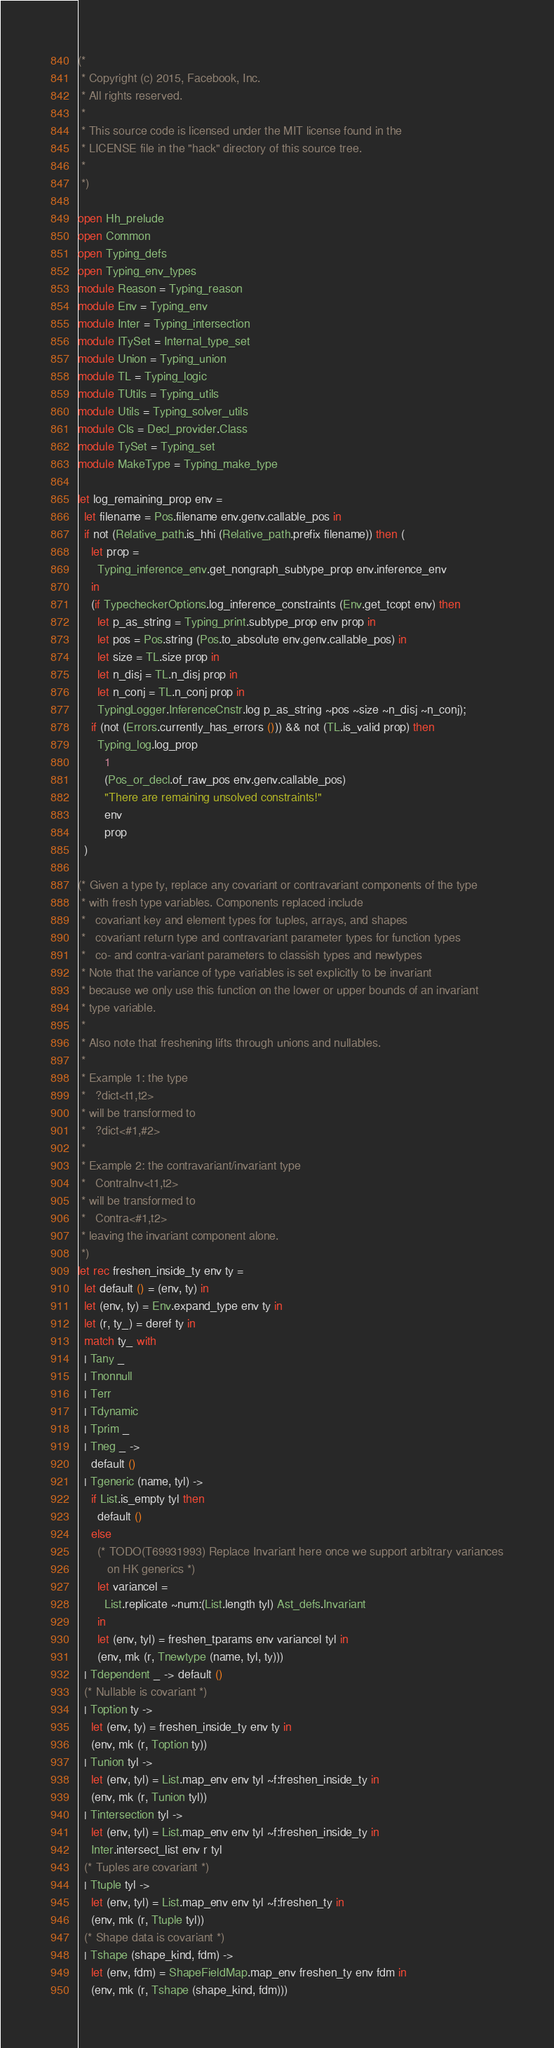<code> <loc_0><loc_0><loc_500><loc_500><_OCaml_>(*
 * Copyright (c) 2015, Facebook, Inc.
 * All rights reserved.
 *
 * This source code is licensed under the MIT license found in the
 * LICENSE file in the "hack" directory of this source tree.
 *
 *)

open Hh_prelude
open Common
open Typing_defs
open Typing_env_types
module Reason = Typing_reason
module Env = Typing_env
module Inter = Typing_intersection
module ITySet = Internal_type_set
module Union = Typing_union
module TL = Typing_logic
module TUtils = Typing_utils
module Utils = Typing_solver_utils
module Cls = Decl_provider.Class
module TySet = Typing_set
module MakeType = Typing_make_type

let log_remaining_prop env =
  let filename = Pos.filename env.genv.callable_pos in
  if not (Relative_path.is_hhi (Relative_path.prefix filename)) then (
    let prop =
      Typing_inference_env.get_nongraph_subtype_prop env.inference_env
    in
    (if TypecheckerOptions.log_inference_constraints (Env.get_tcopt env) then
      let p_as_string = Typing_print.subtype_prop env prop in
      let pos = Pos.string (Pos.to_absolute env.genv.callable_pos) in
      let size = TL.size prop in
      let n_disj = TL.n_disj prop in
      let n_conj = TL.n_conj prop in
      TypingLogger.InferenceCnstr.log p_as_string ~pos ~size ~n_disj ~n_conj);
    if (not (Errors.currently_has_errors ())) && not (TL.is_valid prop) then
      Typing_log.log_prop
        1
        (Pos_or_decl.of_raw_pos env.genv.callable_pos)
        "There are remaining unsolved constraints!"
        env
        prop
  )

(* Given a type ty, replace any covariant or contravariant components of the type
 * with fresh type variables. Components replaced include
 *   covariant key and element types for tuples, arrays, and shapes
 *   covariant return type and contravariant parameter types for function types
 *   co- and contra-variant parameters to classish types and newtypes
 * Note that the variance of type variables is set explicitly to be invariant
 * because we only use this function on the lower or upper bounds of an invariant
 * type variable.
 *
 * Also note that freshening lifts through unions and nullables.
 *
 * Example 1: the type
 *   ?dict<t1,t2>
 * will be transformed to
 *   ?dict<#1,#2>
 *
 * Example 2: the contravariant/invariant type
 *   ContraInv<t1,t2>
 * will be transformed to
 *   Contra<#1,t2>
 * leaving the invariant component alone.
 *)
let rec freshen_inside_ty env ty =
  let default () = (env, ty) in
  let (env, ty) = Env.expand_type env ty in
  let (r, ty_) = deref ty in
  match ty_ with
  | Tany _
  | Tnonnull
  | Terr
  | Tdynamic
  | Tprim _
  | Tneg _ ->
    default ()
  | Tgeneric (name, tyl) ->
    if List.is_empty tyl then
      default ()
    else
      (* TODO(T69931993) Replace Invariant here once we support arbitrary variances
         on HK generics *)
      let variancel =
        List.replicate ~num:(List.length tyl) Ast_defs.Invariant
      in
      let (env, tyl) = freshen_tparams env variancel tyl in
      (env, mk (r, Tnewtype (name, tyl, ty)))
  | Tdependent _ -> default ()
  (* Nullable is covariant *)
  | Toption ty ->
    let (env, ty) = freshen_inside_ty env ty in
    (env, mk (r, Toption ty))
  | Tunion tyl ->
    let (env, tyl) = List.map_env env tyl ~f:freshen_inside_ty in
    (env, mk (r, Tunion tyl))
  | Tintersection tyl ->
    let (env, tyl) = List.map_env env tyl ~f:freshen_inside_ty in
    Inter.intersect_list env r tyl
  (* Tuples are covariant *)
  | Ttuple tyl ->
    let (env, tyl) = List.map_env env tyl ~f:freshen_ty in
    (env, mk (r, Ttuple tyl))
  (* Shape data is covariant *)
  | Tshape (shape_kind, fdm) ->
    let (env, fdm) = ShapeFieldMap.map_env freshen_ty env fdm in
    (env, mk (r, Tshape (shape_kind, fdm)))</code> 